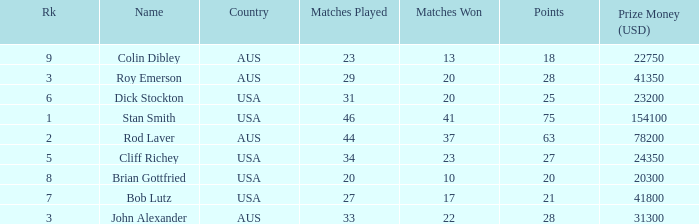How many matches did colin dibley win 13.0. 